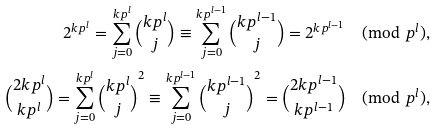<formula> <loc_0><loc_0><loc_500><loc_500>2 ^ { k p ^ { l } } = \sum _ { j = 0 } ^ { k p ^ { l } } \binom { k p ^ { l } } { j } \equiv \sum _ { j = 0 } ^ { k p ^ { l - 1 } } \binom { k p ^ { l - 1 } } { j } = 2 ^ { k p ^ { l - 1 } } \pmod { p ^ { l } } , \\ \binom { 2 k p ^ { l } } { k p ^ { l } } = \sum _ { j = 0 } ^ { k p ^ { l } } \binom { k p ^ { l } } { j } ^ { 2 } \equiv \sum _ { j = 0 } ^ { k p ^ { l - 1 } } \binom { k p ^ { l - 1 } } { j } ^ { 2 } = \binom { 2 k p ^ { l - 1 } } { k p ^ { l - 1 } } \pmod { p ^ { l } } ,</formula> 